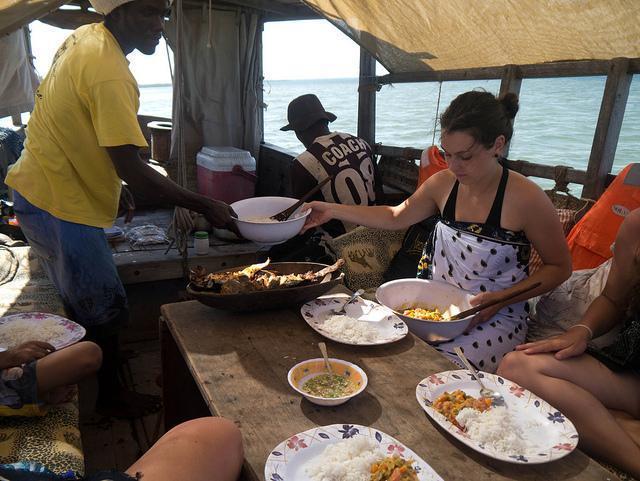How many dishes are on the table?
Give a very brief answer. 5. How many dining tables are there?
Give a very brief answer. 2. How many bowls are there?
Give a very brief answer. 3. How many people can you see?
Give a very brief answer. 6. How many people are waiting at the bus station?
Give a very brief answer. 0. 